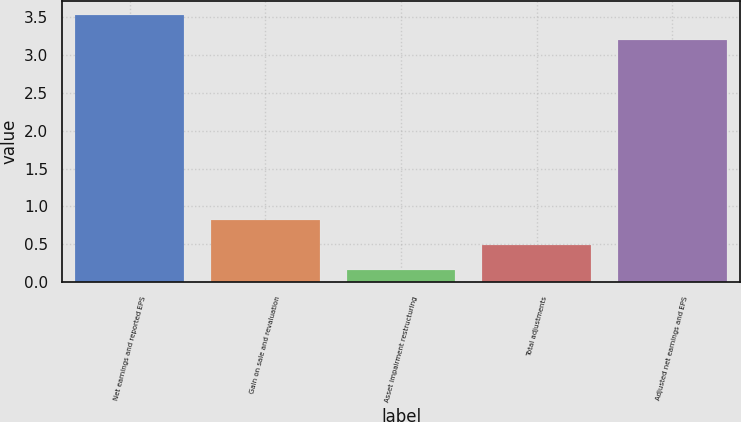Convert chart to OTSL. <chart><loc_0><loc_0><loc_500><loc_500><bar_chart><fcel>Net earnings and reported EPS<fcel>Gain on sale and revaluation<fcel>Asset impairment restructuring<fcel>Total adjustments<fcel>Adjusted net earnings and EPS<nl><fcel>3.53<fcel>0.82<fcel>0.16<fcel>0.49<fcel>3.2<nl></chart> 